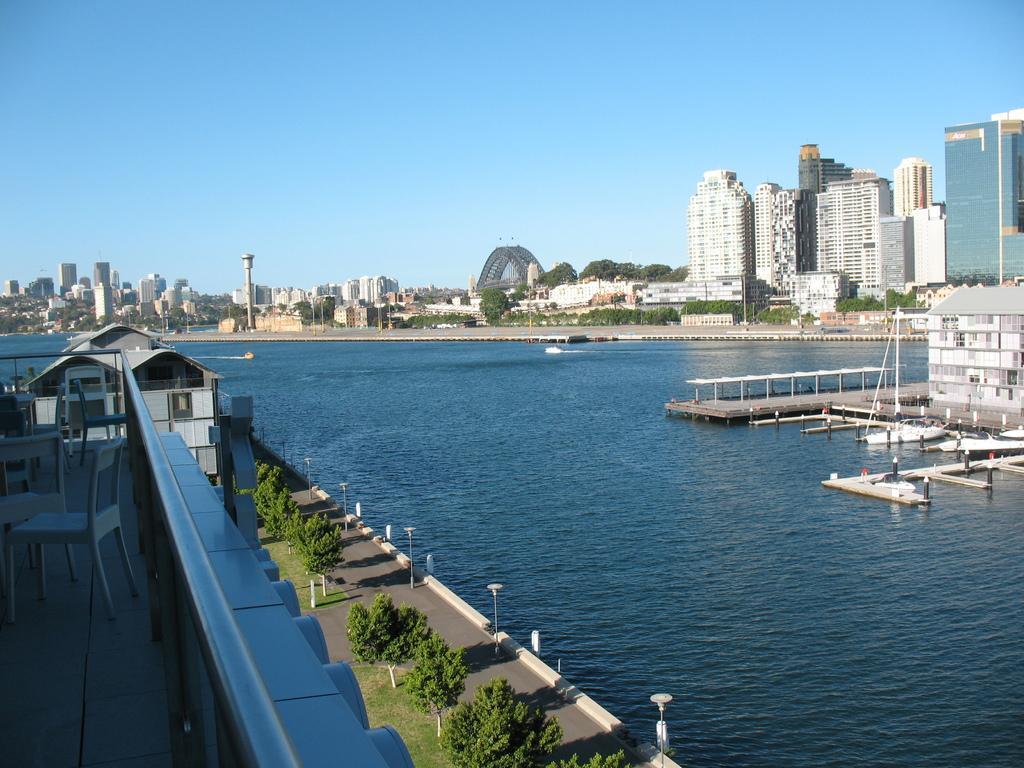Can you describe this image briefly? In the middle of the image I can see water surface and plants. On the right and left side of the image I can see the buildings. In the background, I can see the buildings. 